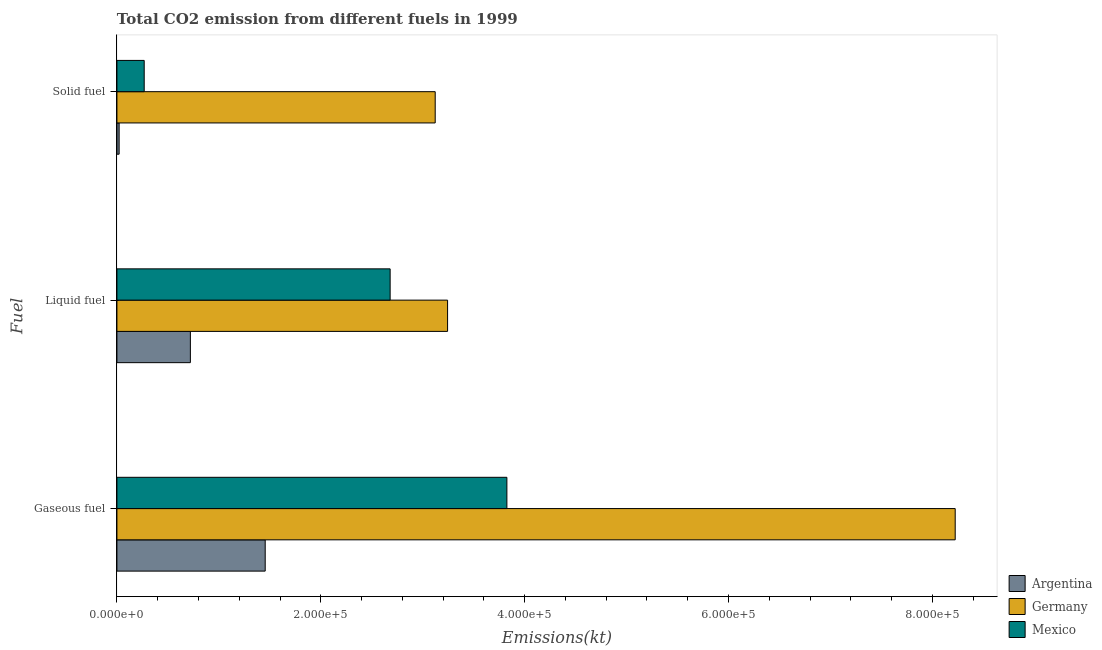How many groups of bars are there?
Provide a short and direct response. 3. Are the number of bars on each tick of the Y-axis equal?
Provide a short and direct response. Yes. How many bars are there on the 2nd tick from the bottom?
Ensure brevity in your answer.  3. What is the label of the 1st group of bars from the top?
Keep it short and to the point. Solid fuel. What is the amount of co2 emissions from liquid fuel in Mexico?
Your answer should be very brief. 2.68e+05. Across all countries, what is the maximum amount of co2 emissions from liquid fuel?
Give a very brief answer. 3.24e+05. Across all countries, what is the minimum amount of co2 emissions from gaseous fuel?
Keep it short and to the point. 1.45e+05. In which country was the amount of co2 emissions from gaseous fuel minimum?
Give a very brief answer. Argentina. What is the total amount of co2 emissions from liquid fuel in the graph?
Offer a very short reply. 6.65e+05. What is the difference between the amount of co2 emissions from liquid fuel in Mexico and that in Argentina?
Give a very brief answer. 1.96e+05. What is the difference between the amount of co2 emissions from gaseous fuel in Mexico and the amount of co2 emissions from liquid fuel in Argentina?
Ensure brevity in your answer.  3.11e+05. What is the average amount of co2 emissions from liquid fuel per country?
Keep it short and to the point. 2.22e+05. What is the difference between the amount of co2 emissions from gaseous fuel and amount of co2 emissions from solid fuel in Germany?
Provide a succinct answer. 5.10e+05. What is the ratio of the amount of co2 emissions from solid fuel in Argentina to that in Mexico?
Offer a terse response. 0.08. Is the amount of co2 emissions from liquid fuel in Mexico less than that in Argentina?
Your answer should be very brief. No. What is the difference between the highest and the second highest amount of co2 emissions from gaseous fuel?
Offer a very short reply. 4.40e+05. What is the difference between the highest and the lowest amount of co2 emissions from solid fuel?
Ensure brevity in your answer.  3.10e+05. In how many countries, is the amount of co2 emissions from gaseous fuel greater than the average amount of co2 emissions from gaseous fuel taken over all countries?
Provide a succinct answer. 1. How many bars are there?
Provide a succinct answer. 9. How many countries are there in the graph?
Your response must be concise. 3. Are the values on the major ticks of X-axis written in scientific E-notation?
Keep it short and to the point. Yes. Does the graph contain grids?
Offer a very short reply. No. Where does the legend appear in the graph?
Keep it short and to the point. Bottom right. How many legend labels are there?
Offer a very short reply. 3. What is the title of the graph?
Your answer should be very brief. Total CO2 emission from different fuels in 1999. What is the label or title of the X-axis?
Give a very brief answer. Emissions(kt). What is the label or title of the Y-axis?
Give a very brief answer. Fuel. What is the Emissions(kt) of Argentina in Gaseous fuel?
Provide a succinct answer. 1.45e+05. What is the Emissions(kt) in Germany in Gaseous fuel?
Your answer should be compact. 8.22e+05. What is the Emissions(kt) of Mexico in Gaseous fuel?
Make the answer very short. 3.83e+05. What is the Emissions(kt) of Argentina in Liquid fuel?
Your answer should be compact. 7.21e+04. What is the Emissions(kt) of Germany in Liquid fuel?
Provide a short and direct response. 3.24e+05. What is the Emissions(kt) of Mexico in Liquid fuel?
Give a very brief answer. 2.68e+05. What is the Emissions(kt) of Argentina in Solid fuel?
Offer a very short reply. 2156.2. What is the Emissions(kt) in Germany in Solid fuel?
Make the answer very short. 3.12e+05. What is the Emissions(kt) of Mexico in Solid fuel?
Keep it short and to the point. 2.68e+04. Across all Fuel, what is the maximum Emissions(kt) in Argentina?
Make the answer very short. 1.45e+05. Across all Fuel, what is the maximum Emissions(kt) in Germany?
Keep it short and to the point. 8.22e+05. Across all Fuel, what is the maximum Emissions(kt) in Mexico?
Keep it short and to the point. 3.83e+05. Across all Fuel, what is the minimum Emissions(kt) of Argentina?
Your response must be concise. 2156.2. Across all Fuel, what is the minimum Emissions(kt) in Germany?
Provide a short and direct response. 3.12e+05. Across all Fuel, what is the minimum Emissions(kt) in Mexico?
Give a very brief answer. 2.68e+04. What is the total Emissions(kt) of Argentina in the graph?
Offer a terse response. 2.20e+05. What is the total Emissions(kt) of Germany in the graph?
Give a very brief answer. 1.46e+06. What is the total Emissions(kt) of Mexico in the graph?
Provide a succinct answer. 6.77e+05. What is the difference between the Emissions(kt) in Argentina in Gaseous fuel and that in Liquid fuel?
Offer a very short reply. 7.34e+04. What is the difference between the Emissions(kt) in Germany in Gaseous fuel and that in Liquid fuel?
Keep it short and to the point. 4.98e+05. What is the difference between the Emissions(kt) in Mexico in Gaseous fuel and that in Liquid fuel?
Your response must be concise. 1.15e+05. What is the difference between the Emissions(kt) of Argentina in Gaseous fuel and that in Solid fuel?
Ensure brevity in your answer.  1.43e+05. What is the difference between the Emissions(kt) of Germany in Gaseous fuel and that in Solid fuel?
Offer a very short reply. 5.10e+05. What is the difference between the Emissions(kt) in Mexico in Gaseous fuel and that in Solid fuel?
Your answer should be very brief. 3.56e+05. What is the difference between the Emissions(kt) of Argentina in Liquid fuel and that in Solid fuel?
Provide a short and direct response. 6.99e+04. What is the difference between the Emissions(kt) in Germany in Liquid fuel and that in Solid fuel?
Your answer should be very brief. 1.21e+04. What is the difference between the Emissions(kt) in Mexico in Liquid fuel and that in Solid fuel?
Give a very brief answer. 2.41e+05. What is the difference between the Emissions(kt) in Argentina in Gaseous fuel and the Emissions(kt) in Germany in Liquid fuel?
Provide a short and direct response. -1.79e+05. What is the difference between the Emissions(kt) in Argentina in Gaseous fuel and the Emissions(kt) in Mexico in Liquid fuel?
Provide a succinct answer. -1.23e+05. What is the difference between the Emissions(kt) in Germany in Gaseous fuel and the Emissions(kt) in Mexico in Liquid fuel?
Your answer should be very brief. 5.54e+05. What is the difference between the Emissions(kt) of Argentina in Gaseous fuel and the Emissions(kt) of Germany in Solid fuel?
Give a very brief answer. -1.67e+05. What is the difference between the Emissions(kt) of Argentina in Gaseous fuel and the Emissions(kt) of Mexico in Solid fuel?
Your response must be concise. 1.19e+05. What is the difference between the Emissions(kt) of Germany in Gaseous fuel and the Emissions(kt) of Mexico in Solid fuel?
Give a very brief answer. 7.96e+05. What is the difference between the Emissions(kt) of Argentina in Liquid fuel and the Emissions(kt) of Germany in Solid fuel?
Give a very brief answer. -2.40e+05. What is the difference between the Emissions(kt) in Argentina in Liquid fuel and the Emissions(kt) in Mexico in Solid fuel?
Your response must be concise. 4.53e+04. What is the difference between the Emissions(kt) in Germany in Liquid fuel and the Emissions(kt) in Mexico in Solid fuel?
Ensure brevity in your answer.  2.98e+05. What is the average Emissions(kt) in Argentina per Fuel?
Your answer should be compact. 7.32e+04. What is the average Emissions(kt) in Germany per Fuel?
Your answer should be compact. 4.86e+05. What is the average Emissions(kt) in Mexico per Fuel?
Provide a short and direct response. 2.26e+05. What is the difference between the Emissions(kt) of Argentina and Emissions(kt) of Germany in Gaseous fuel?
Make the answer very short. -6.77e+05. What is the difference between the Emissions(kt) in Argentina and Emissions(kt) in Mexico in Gaseous fuel?
Offer a terse response. -2.37e+05. What is the difference between the Emissions(kt) in Germany and Emissions(kt) in Mexico in Gaseous fuel?
Provide a succinct answer. 4.40e+05. What is the difference between the Emissions(kt) in Argentina and Emissions(kt) in Germany in Liquid fuel?
Make the answer very short. -2.52e+05. What is the difference between the Emissions(kt) in Argentina and Emissions(kt) in Mexico in Liquid fuel?
Give a very brief answer. -1.96e+05. What is the difference between the Emissions(kt) in Germany and Emissions(kt) in Mexico in Liquid fuel?
Provide a short and direct response. 5.64e+04. What is the difference between the Emissions(kt) in Argentina and Emissions(kt) in Germany in Solid fuel?
Give a very brief answer. -3.10e+05. What is the difference between the Emissions(kt) in Argentina and Emissions(kt) in Mexico in Solid fuel?
Provide a succinct answer. -2.46e+04. What is the difference between the Emissions(kt) of Germany and Emissions(kt) of Mexico in Solid fuel?
Your answer should be very brief. 2.86e+05. What is the ratio of the Emissions(kt) of Argentina in Gaseous fuel to that in Liquid fuel?
Provide a short and direct response. 2.02. What is the ratio of the Emissions(kt) of Germany in Gaseous fuel to that in Liquid fuel?
Your answer should be compact. 2.54. What is the ratio of the Emissions(kt) in Mexico in Gaseous fuel to that in Liquid fuel?
Offer a terse response. 1.43. What is the ratio of the Emissions(kt) in Argentina in Gaseous fuel to that in Solid fuel?
Your answer should be very brief. 67.47. What is the ratio of the Emissions(kt) in Germany in Gaseous fuel to that in Solid fuel?
Make the answer very short. 2.63. What is the ratio of the Emissions(kt) of Mexico in Gaseous fuel to that in Solid fuel?
Your answer should be compact. 14.29. What is the ratio of the Emissions(kt) in Argentina in Liquid fuel to that in Solid fuel?
Give a very brief answer. 33.43. What is the ratio of the Emissions(kt) in Germany in Liquid fuel to that in Solid fuel?
Give a very brief answer. 1.04. What is the ratio of the Emissions(kt) in Mexico in Liquid fuel to that in Solid fuel?
Keep it short and to the point. 10.01. What is the difference between the highest and the second highest Emissions(kt) of Argentina?
Your answer should be very brief. 7.34e+04. What is the difference between the highest and the second highest Emissions(kt) of Germany?
Make the answer very short. 4.98e+05. What is the difference between the highest and the second highest Emissions(kt) of Mexico?
Your answer should be very brief. 1.15e+05. What is the difference between the highest and the lowest Emissions(kt) of Argentina?
Your answer should be very brief. 1.43e+05. What is the difference between the highest and the lowest Emissions(kt) in Germany?
Provide a short and direct response. 5.10e+05. What is the difference between the highest and the lowest Emissions(kt) in Mexico?
Give a very brief answer. 3.56e+05. 